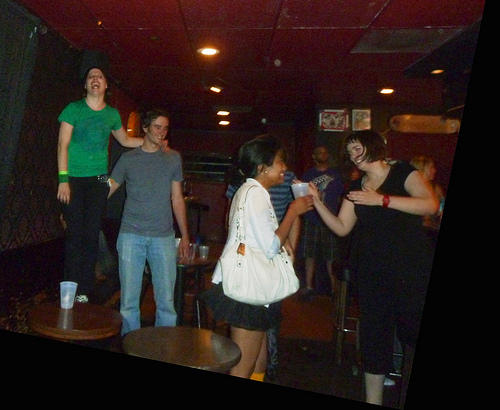<image>
Is there a cup on the table? No. The cup is not positioned on the table. They may be near each other, but the cup is not supported by or resting on top of the table. 